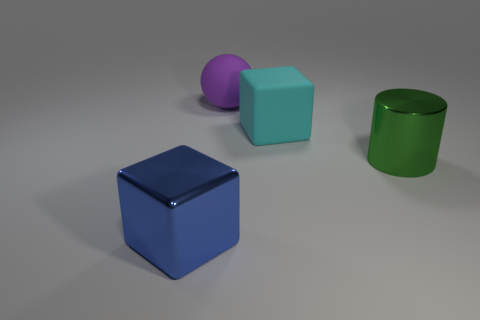Are there fewer large blocks behind the cylinder than large blue cubes behind the cyan matte block?
Ensure brevity in your answer.  No. There is a object that is to the right of the block that is to the right of the big metallic thing that is on the left side of the ball; what shape is it?
Offer a very short reply. Cylinder. How many red objects are either cylinders or big things?
Offer a very short reply. 0. There is a metallic object on the left side of the large purple object; how many cyan rubber things are on the right side of it?
Your answer should be compact. 1. Are there any other things that have the same color as the sphere?
Offer a very short reply. No. There is a object that is made of the same material as the ball; what shape is it?
Ensure brevity in your answer.  Cube. Is the color of the large matte block the same as the shiny block?
Keep it short and to the point. No. Do the big object that is left of the rubber sphere and the cube that is on the right side of the blue block have the same material?
Your response must be concise. No. How many things are either large gray cubes or cubes that are to the left of the big matte sphere?
Your answer should be very brief. 1. Are there any other things that have the same material as the purple sphere?
Your response must be concise. Yes. 